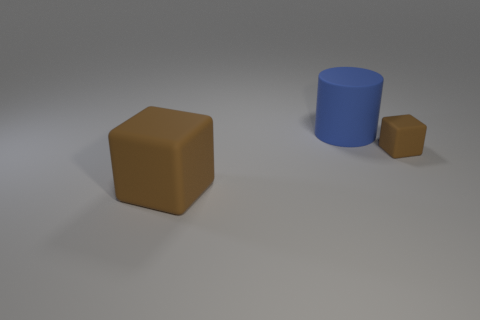Are there any brown objects on the right side of the blue matte cylinder?
Offer a terse response. Yes. What number of tiny rubber objects have the same shape as the big brown matte object?
Your response must be concise. 1. The cube on the left side of the brown block behind the block that is on the left side of the big blue cylinder is what color?
Make the answer very short. Brown. How many things are things right of the big block or large matte cylinders?
Provide a short and direct response. 2. How many objects are either big brown matte cubes or brown objects behind the big block?
Make the answer very short. 2. How many purple metallic things have the same size as the blue cylinder?
Offer a very short reply. 0. Is the number of big brown rubber objects behind the tiny thing less than the number of matte cubes to the left of the large cylinder?
Your answer should be compact. Yes. How many matte objects are either tiny brown cubes or cylinders?
Keep it short and to the point. 2. There is a large blue object; what shape is it?
Your answer should be very brief. Cylinder. How many large objects are gray objects or things?
Your response must be concise. 2. 